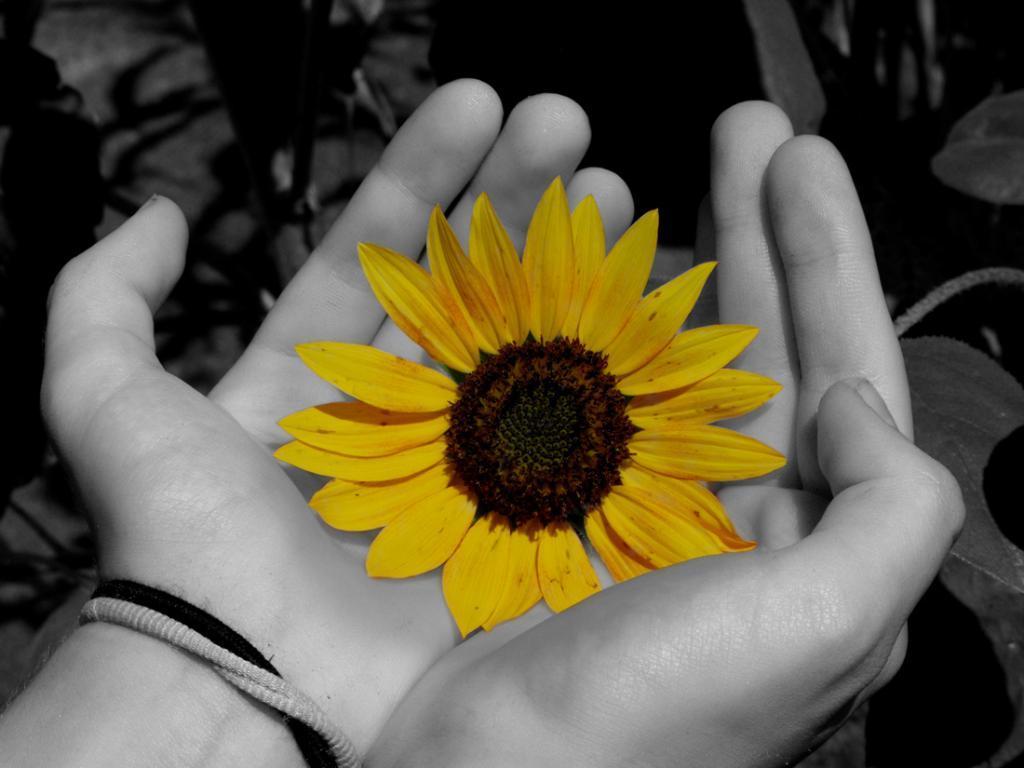Could you give a brief overview of what you see in this image? This picture shows a human hands holding flower and we see plants and the flower is yellow in color. 